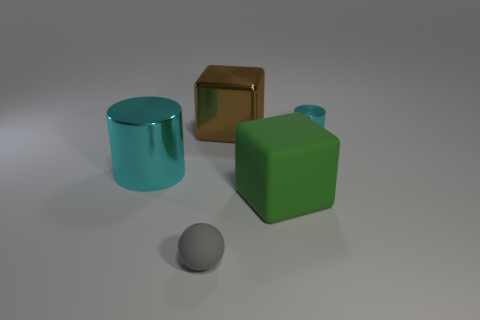Add 3 big blue matte cylinders. How many objects exist? 8 Subtract all spheres. How many objects are left? 4 Add 4 large metal cubes. How many large metal cubes exist? 5 Subtract 0 brown cylinders. How many objects are left? 5 Subtract all big brown cubes. Subtract all metal objects. How many objects are left? 1 Add 4 small matte spheres. How many small matte spheres are left? 5 